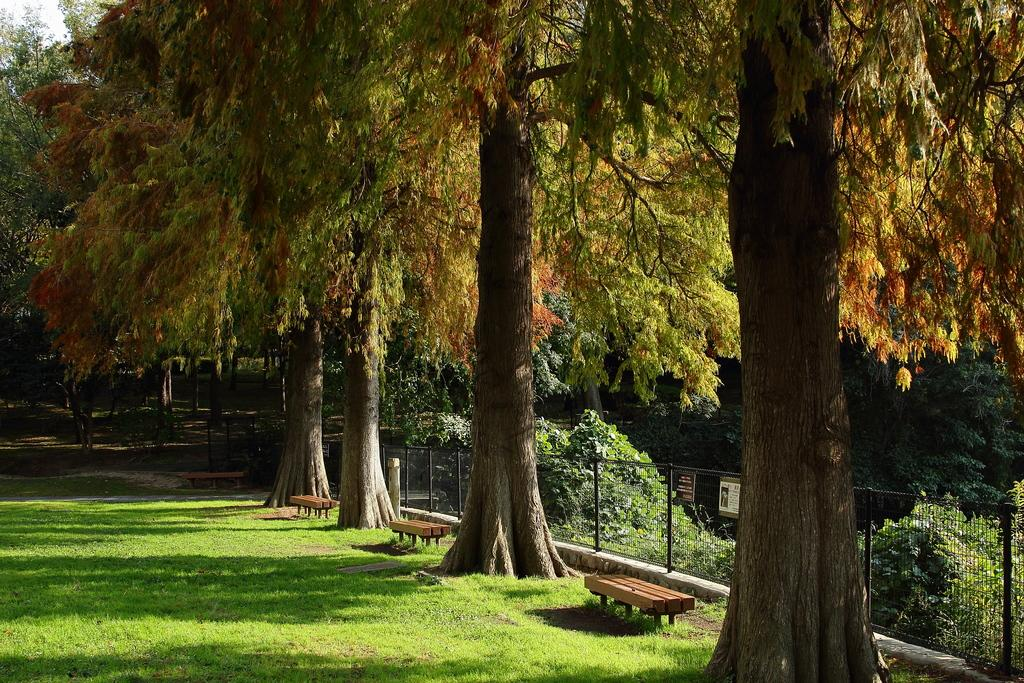What type of vegetation is present in the image? There are trees in the image. What is the location of the benches in the image? The benches are on the grass in the image. Where are the benches positioned in relation to the trees? The benches are beneath the trees in the image. Can you describe the railing and net in the image? There is a railing with a net in the image. What type of silk is draped over the trees in the image? There is no silk present in the image; it features trees, benches, and a railing with a net. 